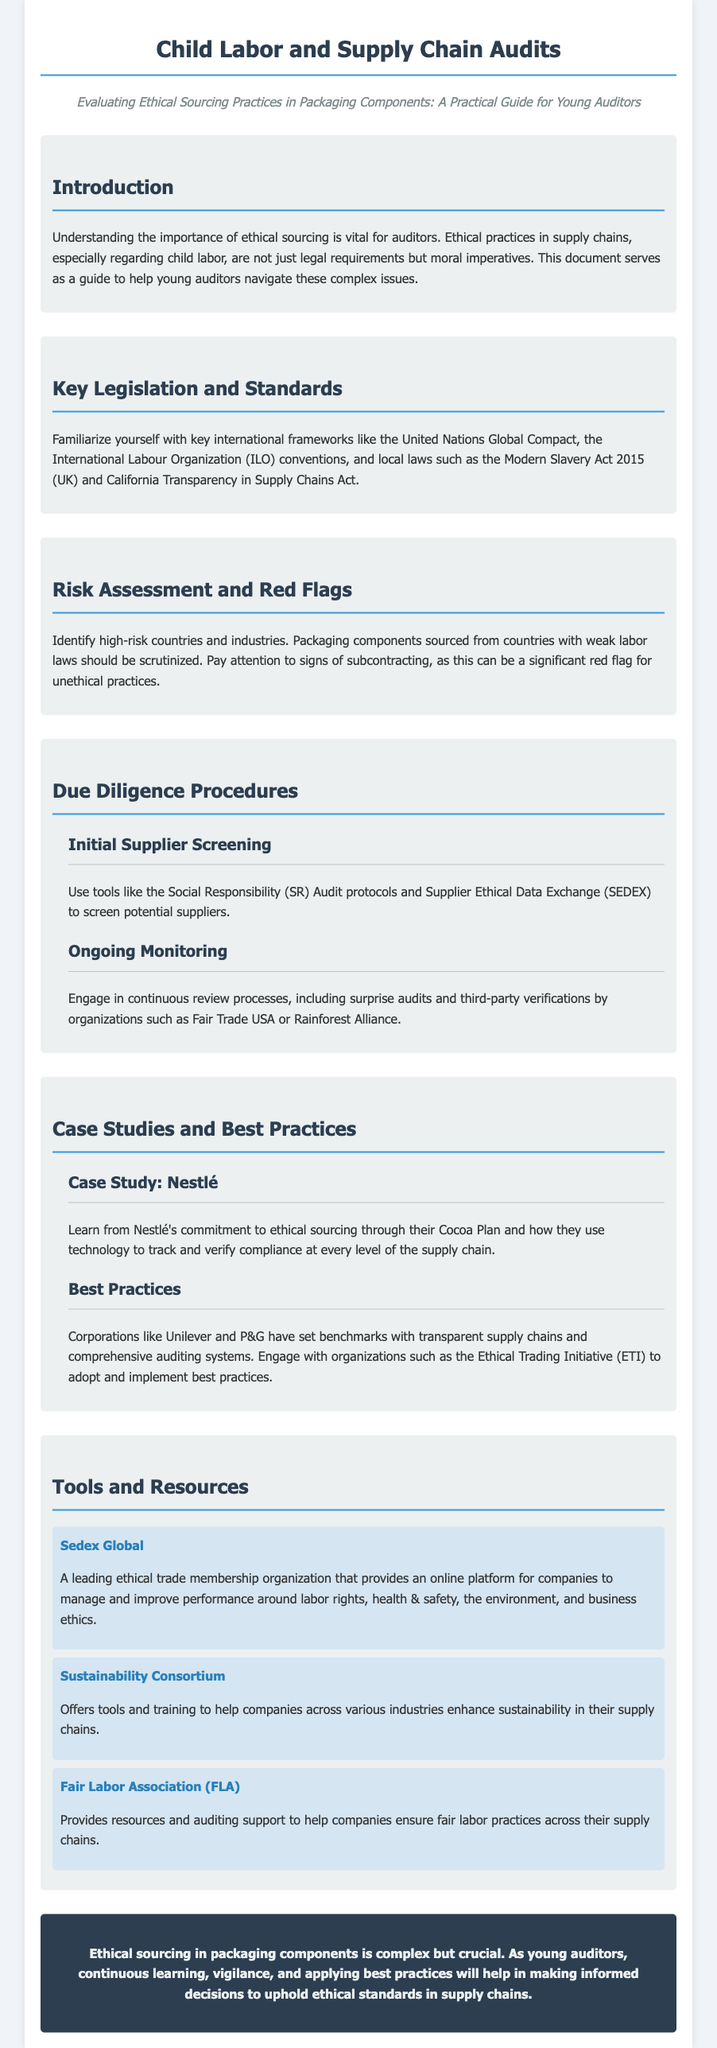What is the title of the document? The title is mentioned in the document header, which indicates its subject matter.
Answer: Child Labor and Supply Chain Audits What is the subtitle of the document? The subtitle appears directly under the title and provides additional context about the document's purpose.
Answer: Evaluating Ethical Sourcing Practices in Packaging Components: A Practical Guide for Young Auditors Which case study is mentioned in the document? The document highlights a specific company example in the case study section.
Answer: Nestlé What organization provides auditing support for fair labor practices? The document lists organizations that assist with ethical sourcing and labor practices.
Answer: Fair Labor Association (FLA) What Act is mentioned as a local law related to supply chains? The document references a specific legal framework related to ethical sourcing in one of the sections.
Answer: Modern Slavery Act 2015 (UK) What are two sources for ongoing monitoring mentioned? The ongoing monitoring section lists organization types that should be engaged for audits.
Answer: Surprise audits and third-party verifications What type of frameworks should auditors familiarize themselves with? The document explicitly states various frameworks that auditor ought to understand for ethical sourcing.
Answer: International frameworks Which two companies are cited as having best practices in the document? The document references specific corporations known for their ethical sourcing practices.
Answer: Unilever and P&G What is the purpose of Sedex Global? The document provides a description of Sedex Global and its objectives in the context of ethical trade.
Answer: Manage and improve performance around labor rights, health & safety, the environment, and business ethics 